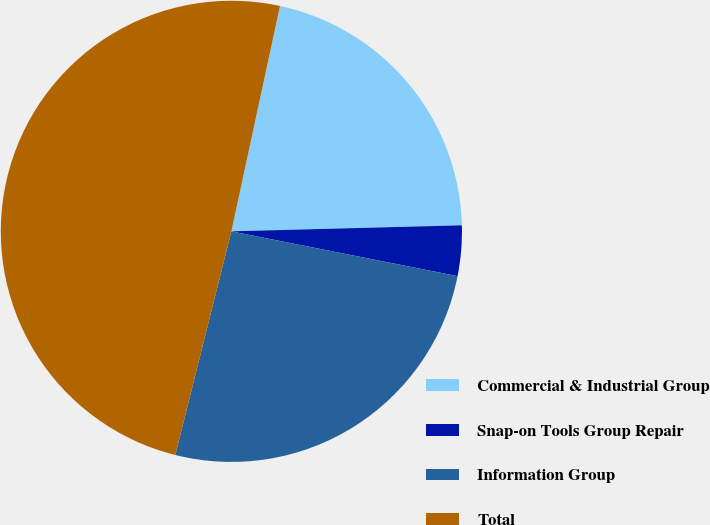<chart> <loc_0><loc_0><loc_500><loc_500><pie_chart><fcel>Commercial & Industrial Group<fcel>Snap-on Tools Group Repair<fcel>Information Group<fcel>Total<nl><fcel>21.2%<fcel>3.53%<fcel>25.8%<fcel>49.47%<nl></chart> 